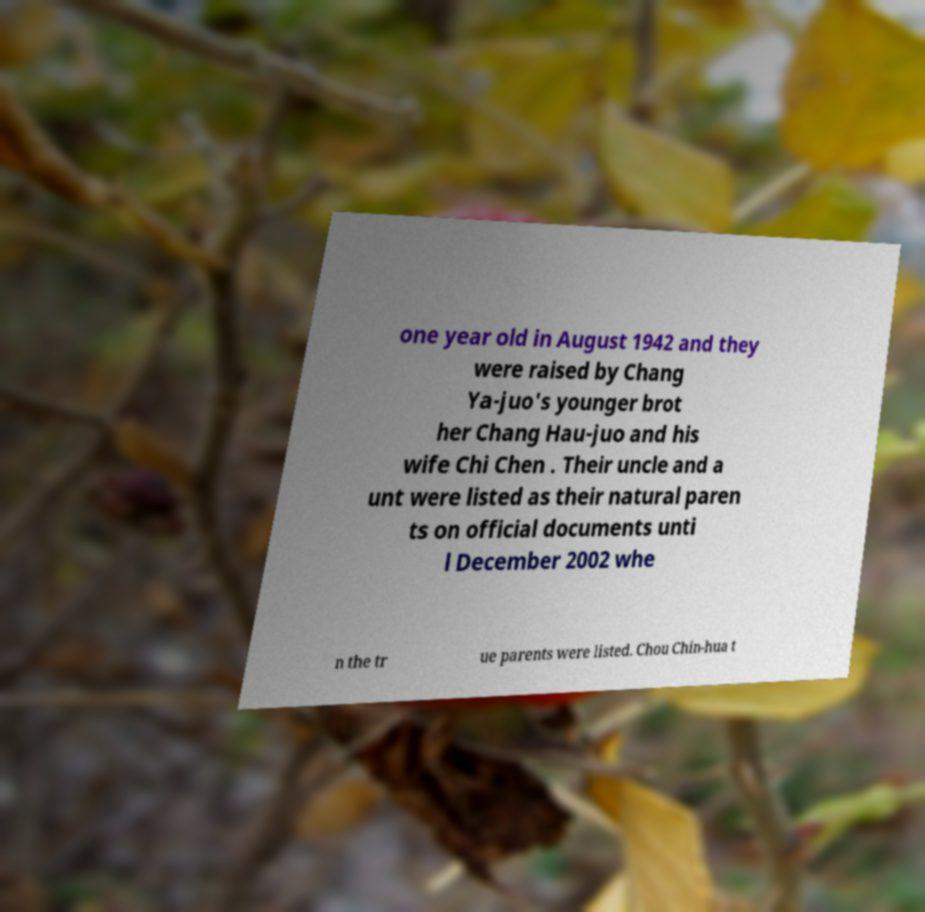Can you accurately transcribe the text from the provided image for me? one year old in August 1942 and they were raised by Chang Ya-juo's younger brot her Chang Hau-juo and his wife Chi Chen . Their uncle and a unt were listed as their natural paren ts on official documents unti l December 2002 whe n the tr ue parents were listed. Chou Chin-hua t 